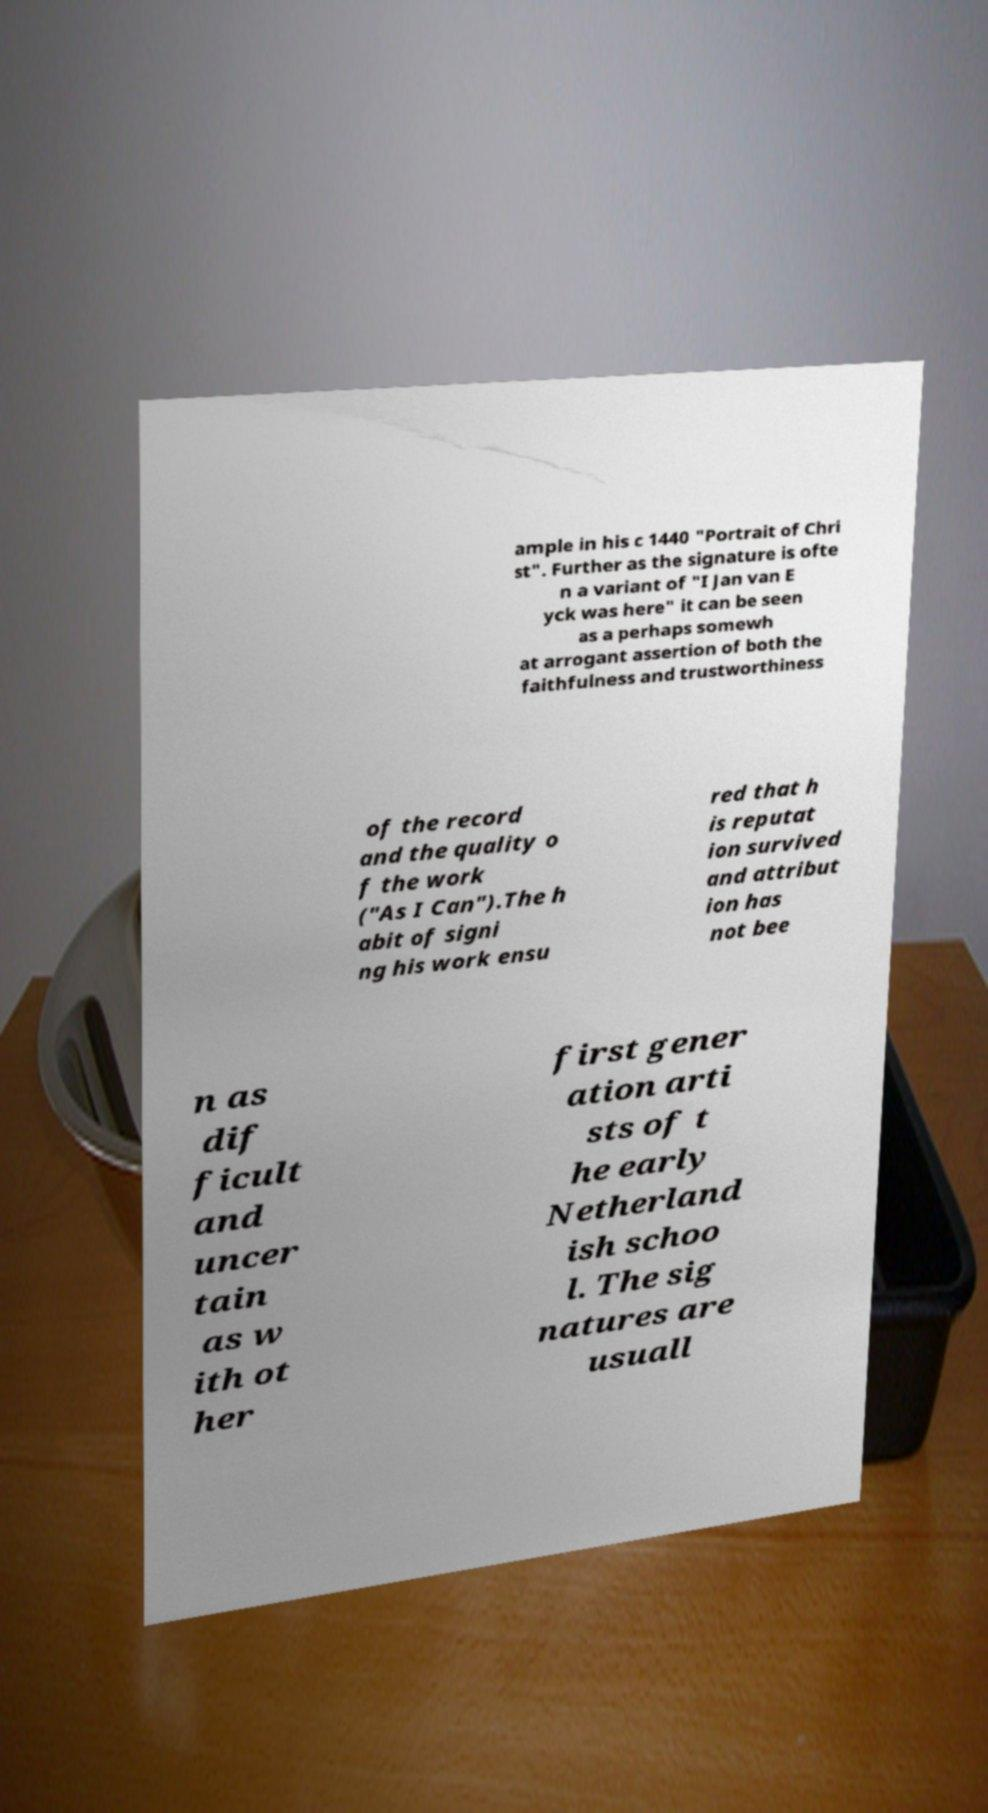Please identify and transcribe the text found in this image. ample in his c 1440 "Portrait of Chri st". Further as the signature is ofte n a variant of "I Jan van E yck was here" it can be seen as a perhaps somewh at arrogant assertion of both the faithfulness and trustworthiness of the record and the quality o f the work ("As I Can").The h abit of signi ng his work ensu red that h is reputat ion survived and attribut ion has not bee n as dif ficult and uncer tain as w ith ot her first gener ation arti sts of t he early Netherland ish schoo l. The sig natures are usuall 